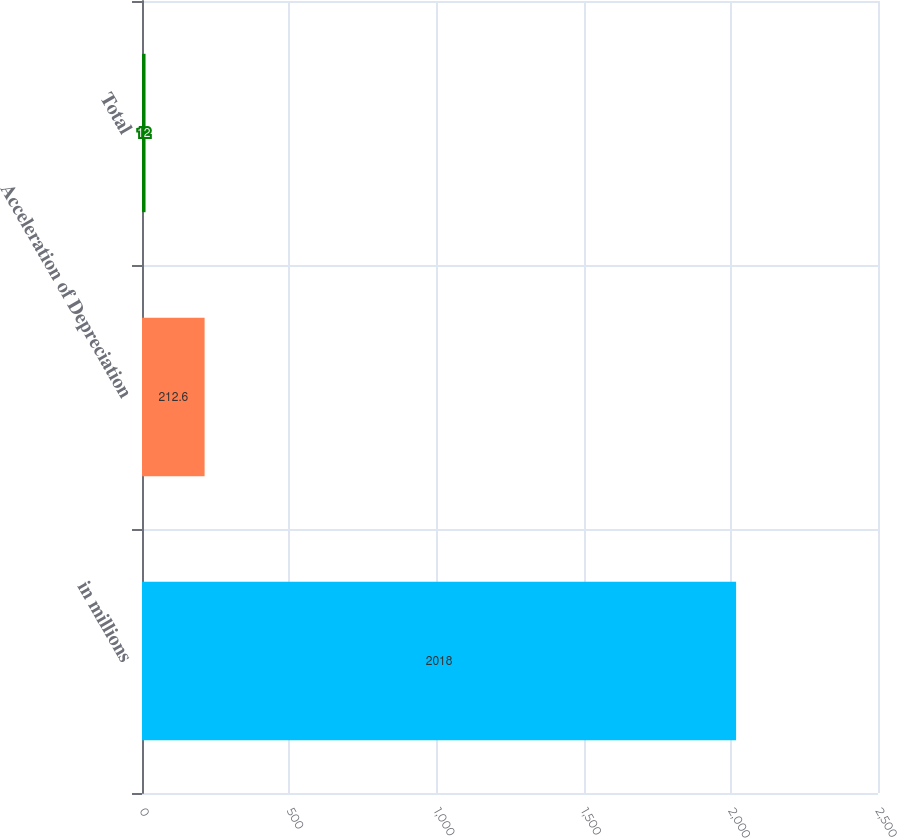Convert chart. <chart><loc_0><loc_0><loc_500><loc_500><bar_chart><fcel>in millions<fcel>Acceleration of Depreciation<fcel>Total<nl><fcel>2018<fcel>212.6<fcel>12<nl></chart> 